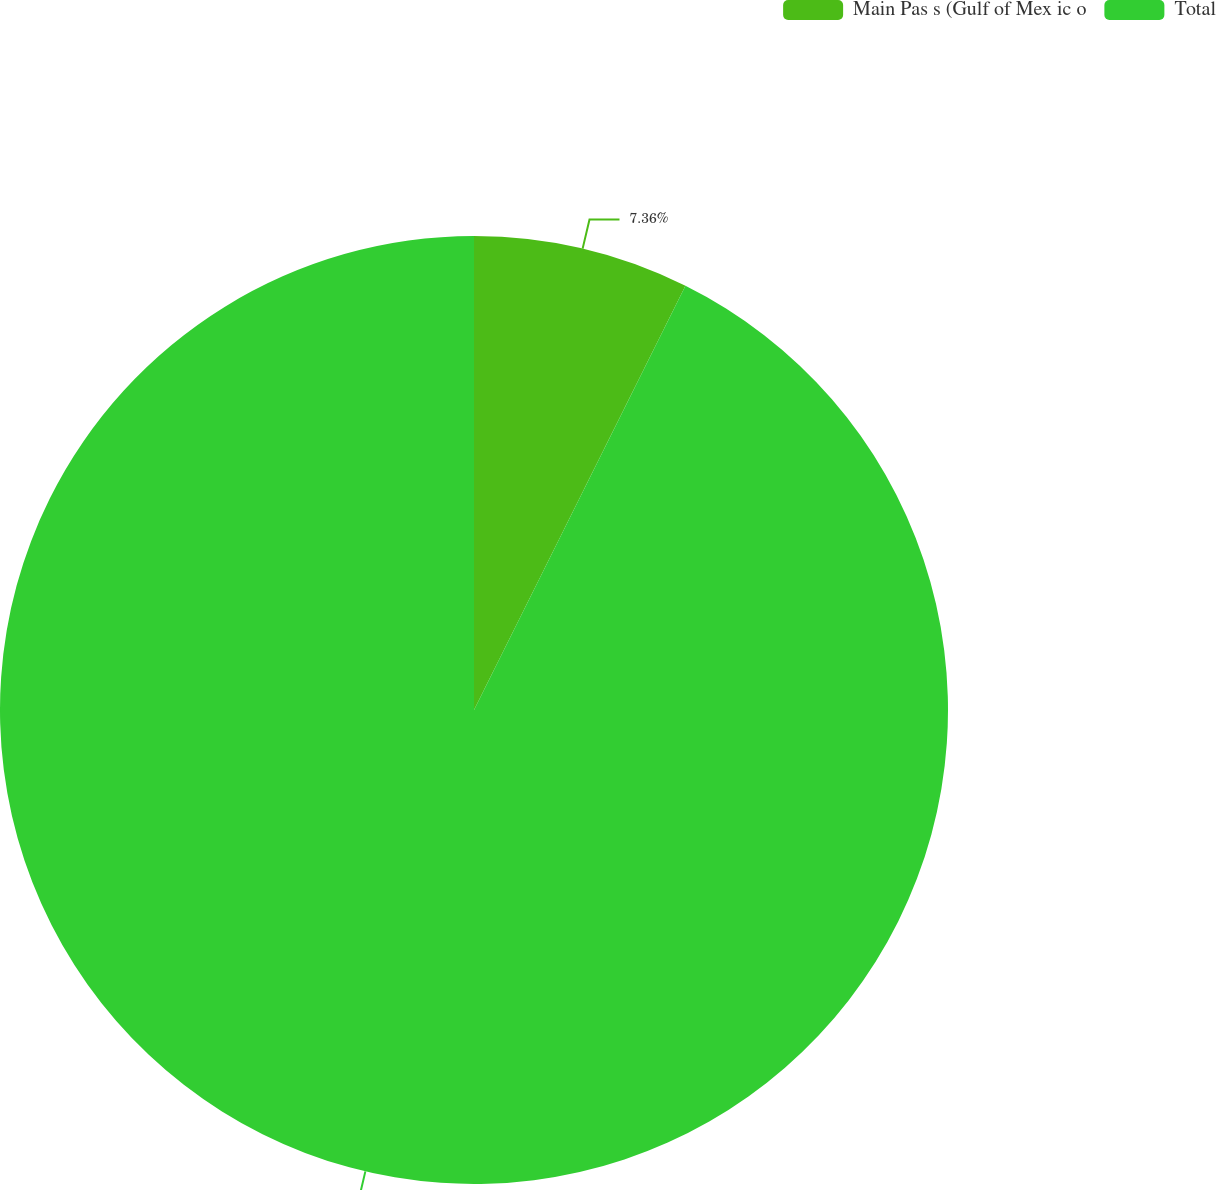Convert chart to OTSL. <chart><loc_0><loc_0><loc_500><loc_500><pie_chart><fcel>Main Pas s (Gulf of Mex ic o<fcel>Total<nl><fcel>7.36%<fcel>92.64%<nl></chart> 